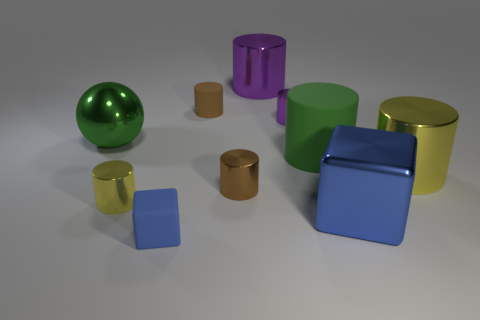Subtract all purple cylinders. How many cylinders are left? 5 Subtract all small cylinders. How many cylinders are left? 3 Subtract 1 cylinders. How many cylinders are left? 6 Subtract all brown cylinders. Subtract all red cubes. How many cylinders are left? 5 Subtract all red balls. How many yellow cylinders are left? 2 Subtract all small things. Subtract all small purple cylinders. How many objects are left? 4 Add 6 purple shiny things. How many purple shiny things are left? 8 Add 4 small blue things. How many small blue things exist? 5 Subtract 0 yellow blocks. How many objects are left? 10 Subtract all spheres. How many objects are left? 9 